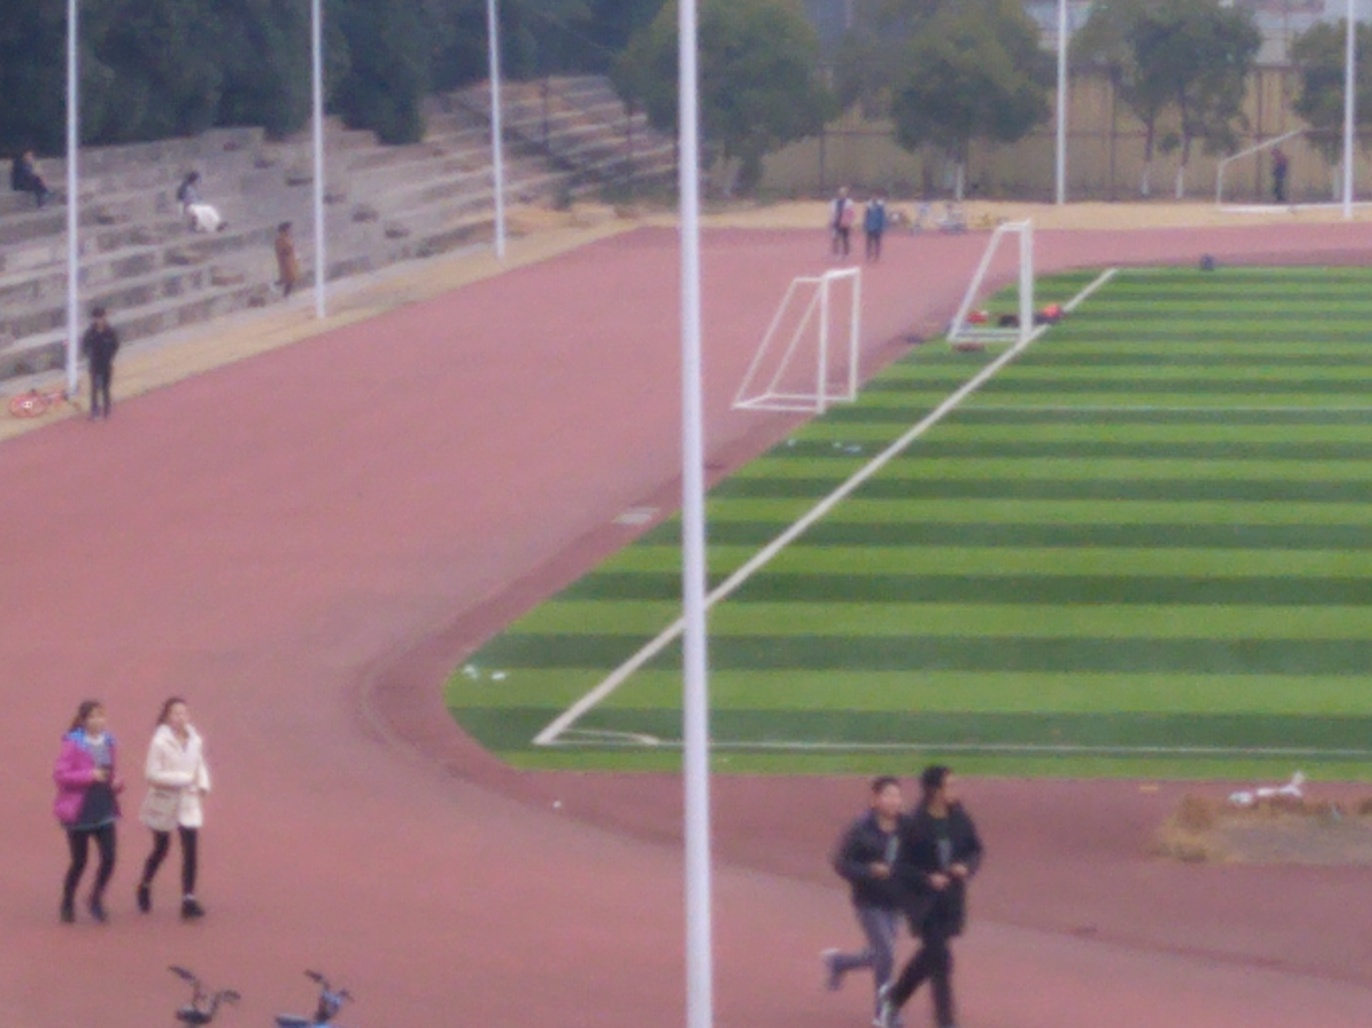What kind of events do you think are held here? Given the presence of a running track and a soccer goal post, this facility is likely used for track and field events as well as football (soccer) matches. It may also serve as a venue for general physical training and school sports days. 